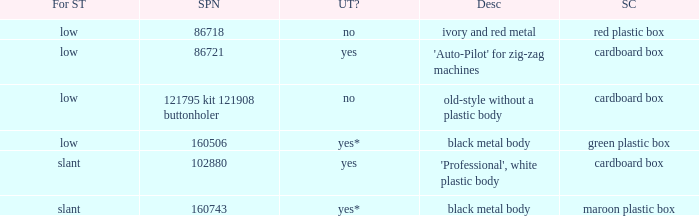What's the storage case of the buttonholer described as ivory and red metal? Red plastic box. 